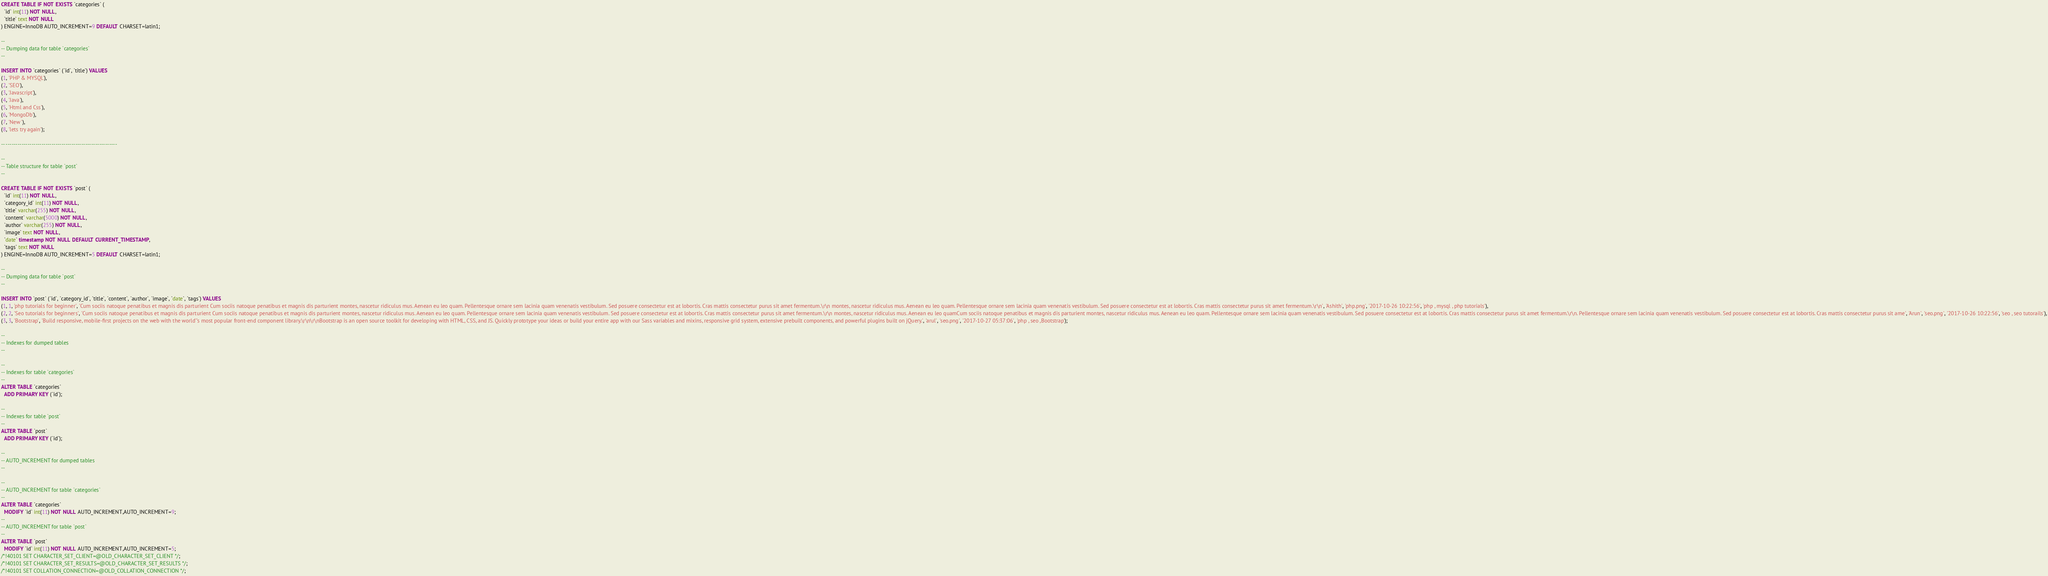<code> <loc_0><loc_0><loc_500><loc_500><_SQL_>
CREATE TABLE IF NOT EXISTS `categories` (
  `id` int(11) NOT NULL,
  `title` text NOT NULL
) ENGINE=InnoDB AUTO_INCREMENT=9 DEFAULT CHARSET=latin1;

--
-- Dumping data for table `categories`
--

INSERT INTO `categories` (`id`, `title`) VALUES
(1, 'PHP & MYSQL'),
(2, 'SEO'),
(3, 'Javascript'),
(4, 'Java'),
(5, 'Html and Css'),
(6, 'MongoDb'),
(7, 'New '),
(8, 'lets try again');

-- --------------------------------------------------------

--
-- Table structure for table `post`
--

CREATE TABLE IF NOT EXISTS `post` (
  `id` int(11) NOT NULL,
  `category_id` int(11) NOT NULL,
  `title` varchar(255) NOT NULL,
  `content` varchar(5000) NOT NULL,
  `author` varchar(255) NOT NULL,
  `image` text NOT NULL,
  `date` timestamp NOT NULL DEFAULT CURRENT_TIMESTAMP,
  `tags` text NOT NULL
) ENGINE=InnoDB AUTO_INCREMENT=5 DEFAULT CHARSET=latin1;

--
-- Dumping data for table `post`
--

INSERT INTO `post` (`id`, `category_id`, `title`, `content`, `author`, `image`, `date`, `tags`) VALUES
(1, 1, 'php tutorials for beginner', 'Cum sociis natoque penatibus et magnis dis parturient Cum sociis natoque penatibus et magnis dis parturient montes, nascetur ridiculus mus. Aenean eu leo quam. Pellentesque ornare sem lacinia quam venenatis vestibulum. Sed posuere consectetur est at lobortis. Cras mattis consectetur purus sit amet fermentum.\r\n montes, nascetur ridiculus mus. Aenean eu leo quam. Pellentesque ornare sem lacinia quam venenatis vestibulum. Sed posuere consectetur est at lobortis. Cras mattis consectetur purus sit amet fermentum.\r\n', 'Ashith', 'php.png', '2017-10-26 10:22:56', 'php , mysql , php tutorials'),
(2, 2, 'Seo tutorials for beginners', 'Cum sociis natoque penatibus et magnis dis parturient Cum sociis natoque penatibus et magnis dis parturient montes, nascetur ridiculus mus. Aenean eu leo quam. Pellentesque ornare sem lacinia quam venenatis vestibulum. Sed posuere consectetur est at lobortis. Cras mattis consectetur purus sit amet fermentum.\r\n montes, nascetur ridiculus mus. Aenean eu leo quamCum sociis natoque penatibus et magnis dis parturient montes, nascetur ridiculus mus. Aenean eu leo quam. Pellentesque ornare sem lacinia quam venenatis vestibulum. Sed posuere consectetur est at lobortis. Cras mattis consectetur purus sit amet fermentum.\r\n. Pellentesque ornare sem lacinia quam venenatis vestibulum. Sed posuere consectetur est at lobortis. Cras mattis consectetur purus sit ame', 'Arun', 'seo.png', '2017-10-26 10:22:56', 'seo , seo tutorails'),
(3, 3, 'Bootstrap', 'Build responsive, mobile-first projects on the web with the world''s most popular front-end component library.\r\n\r\nBootstrap is an open source toolkit for developing with HTML, CSS, and JS. Quickly prototype your ideas or build your entire app with our Sass variables and mixins, responsive grid system, extensive prebuilt components, and powerful plugins built on jQuery.', 'arul', 'seo.png', '2017-10-27 05:37:06', 'php , seo ,Bootstrap');

--
-- Indexes for dumped tables
--

--
-- Indexes for table `categories`
--
ALTER TABLE `categories`
  ADD PRIMARY KEY (`id`);

--
-- Indexes for table `post`
--
ALTER TABLE `post`
  ADD PRIMARY KEY (`id`);

--
-- AUTO_INCREMENT for dumped tables
--

--
-- AUTO_INCREMENT for table `categories`
--
ALTER TABLE `categories`
  MODIFY `id` int(11) NOT NULL AUTO_INCREMENT,AUTO_INCREMENT=9;
--
-- AUTO_INCREMENT for table `post`
--
ALTER TABLE `post`
  MODIFY `id` int(11) NOT NULL AUTO_INCREMENT,AUTO_INCREMENT=5;
/*!40101 SET CHARACTER_SET_CLIENT=@OLD_CHARACTER_SET_CLIENT */;
/*!40101 SET CHARACTER_SET_RESULTS=@OLD_CHARACTER_SET_RESULTS */;
/*!40101 SET COLLATION_CONNECTION=@OLD_COLLATION_CONNECTION */;
</code> 